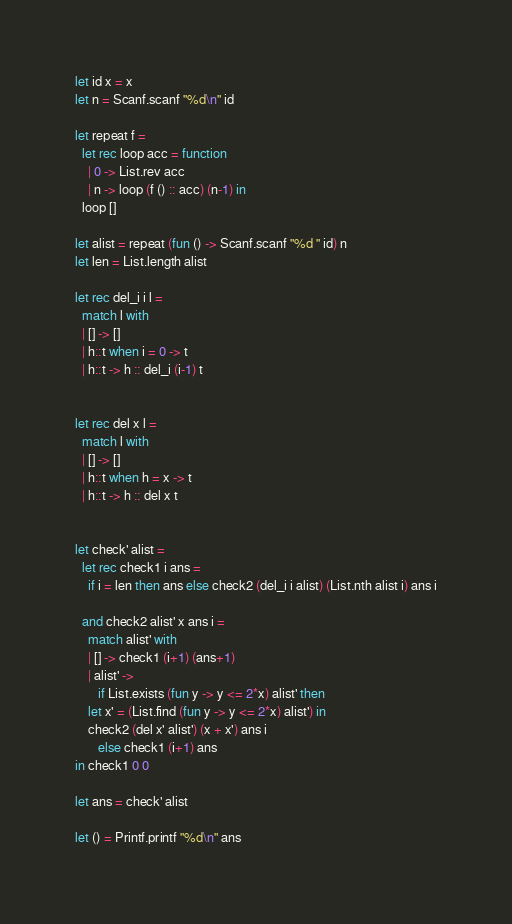<code> <loc_0><loc_0><loc_500><loc_500><_OCaml_>let id x = x
let n = Scanf.scanf "%d\n" id
  
let repeat f =
  let rec loop acc = function
    | 0 -> List.rev acc
    | n -> loop (f () :: acc) (n-1) in
  loop []

let alist = repeat (fun () -> Scanf.scanf "%d " id) n
let len = List.length alist

let rec del_i i l =
  match l with
  | [] -> []
  | h::t when i = 0 -> t
  | h::t -> h :: del_i (i-1) t


let rec del x l =
  match l with
  | [] -> []
  | h::t when h = x -> t
  | h::t -> h :: del x t

  
let check' alist =
  let rec check1 i ans =
    if i = len then ans else check2 (del_i i alist) (List.nth alist i) ans i

  and check2 alist' x ans i =
    match alist' with
    | [] -> check1 (i+1) (ans+1)
    | alist' ->
       if List.exists (fun y -> y <= 2*x) alist' then
	let x' = (List.find (fun y -> y <= 2*x) alist') in
	check2 (del x' alist') (x + x') ans i
       else check1 (i+1) ans
in check1 0 0

let ans = check' alist

let () = Printf.printf "%d\n" ans
</code> 